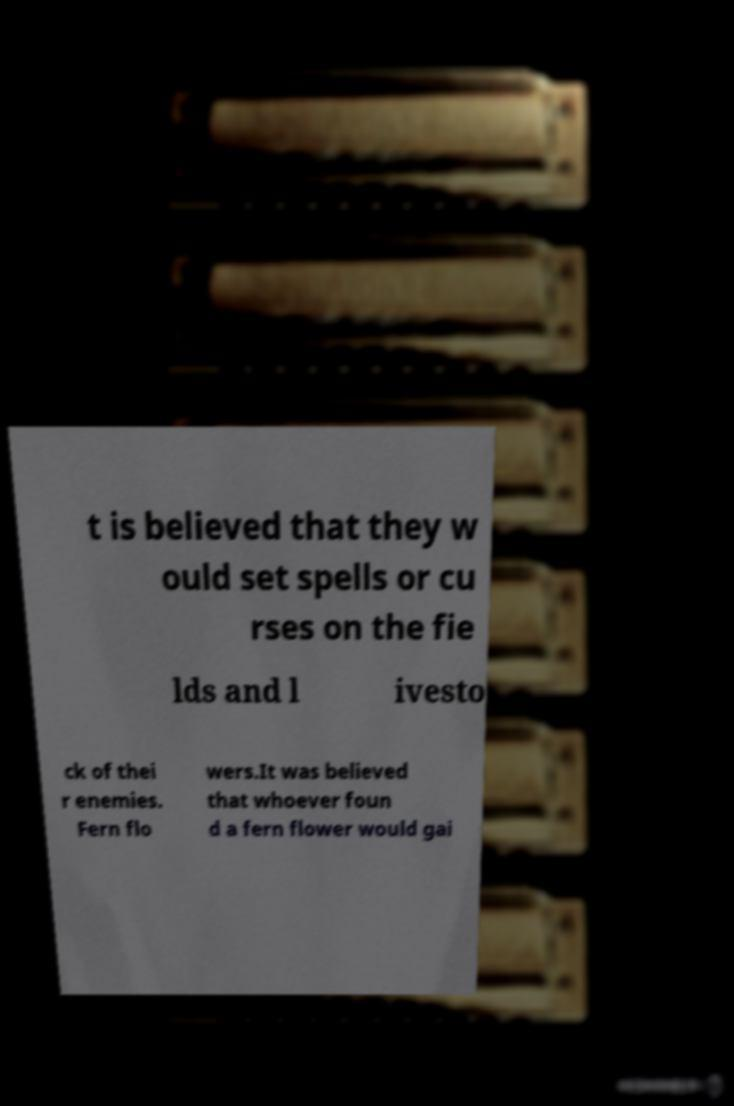For documentation purposes, I need the text within this image transcribed. Could you provide that? t is believed that they w ould set spells or cu rses on the fie lds and l ivesto ck of thei r enemies. Fern flo wers.It was believed that whoever foun d a fern flower would gai 